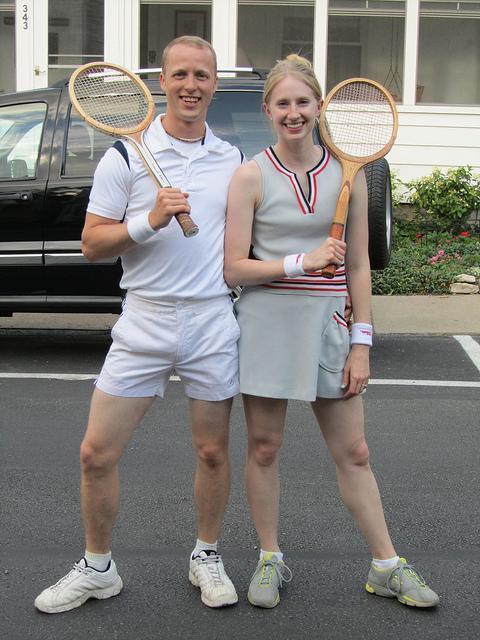How many people can you see?
Give a very brief answer. 2. How many tennis rackets are there?
Give a very brief answer. 2. How many trucks can you see?
Give a very brief answer. 1. 